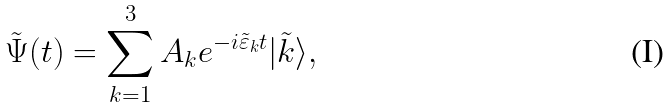<formula> <loc_0><loc_0><loc_500><loc_500>\tilde { \Psi } ( t ) = \sum _ { k = 1 } ^ { 3 } A _ { k } e ^ { - i \tilde { \varepsilon } _ { k } t } | \tilde { k } \rangle ,</formula> 